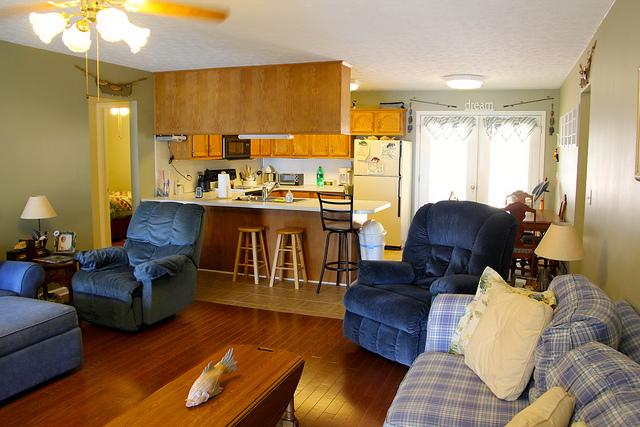Is there a fish on the coffee table?
Keep it brief. Yes. Are the recliners the same color?
Keep it brief. Yes. Is the light on?
Short answer required. Yes. 